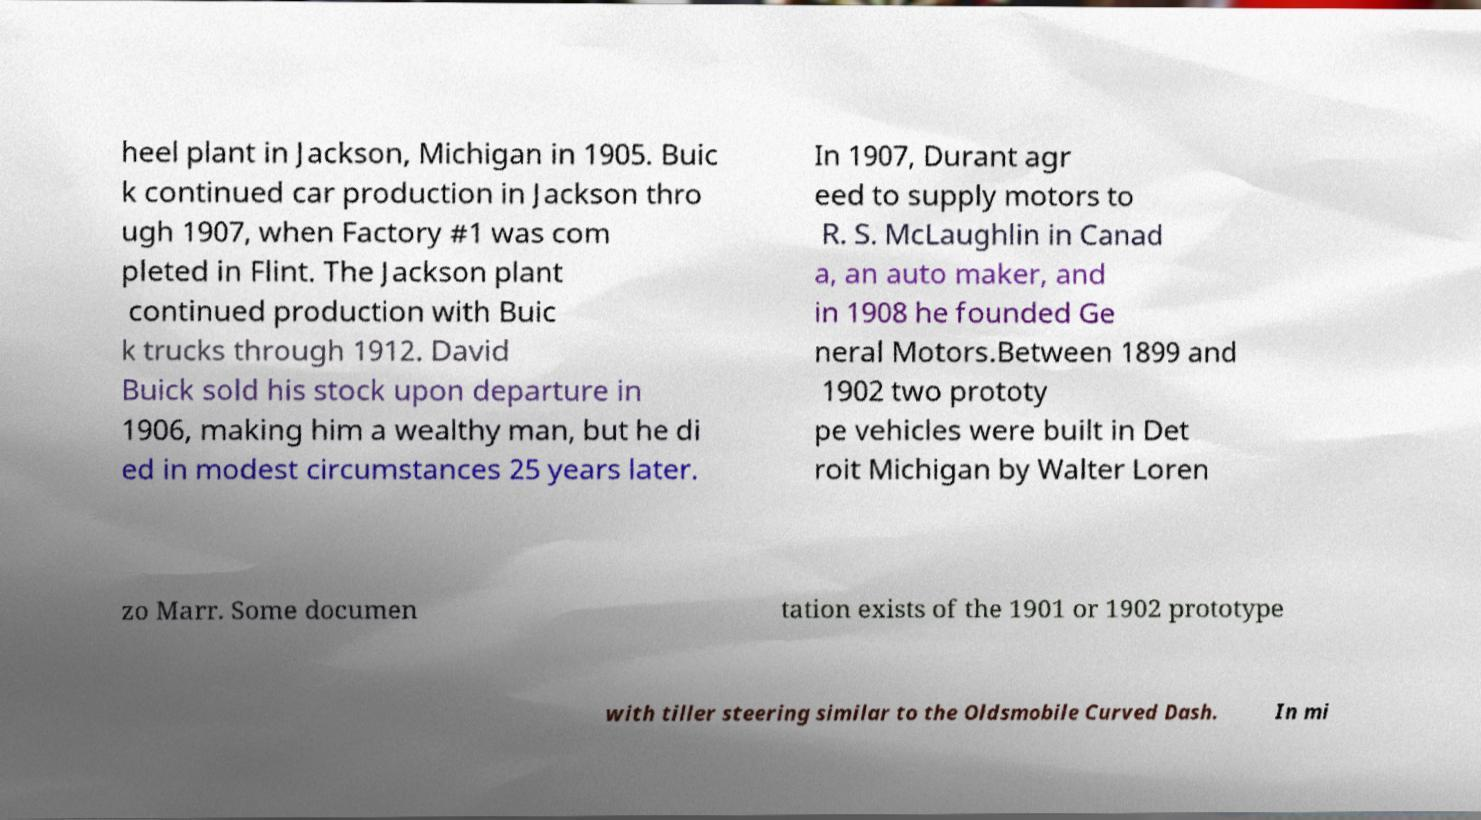Could you extract and type out the text from this image? heel plant in Jackson, Michigan in 1905. Buic k continued car production in Jackson thro ugh 1907, when Factory #1 was com pleted in Flint. The Jackson plant continued production with Buic k trucks through 1912. David Buick sold his stock upon departure in 1906, making him a wealthy man, but he di ed in modest circumstances 25 years later. In 1907, Durant agr eed to supply motors to R. S. McLaughlin in Canad a, an auto maker, and in 1908 he founded Ge neral Motors.Between 1899 and 1902 two prototy pe vehicles were built in Det roit Michigan by Walter Loren zo Marr. Some documen tation exists of the 1901 or 1902 prototype with tiller steering similar to the Oldsmobile Curved Dash. In mi 